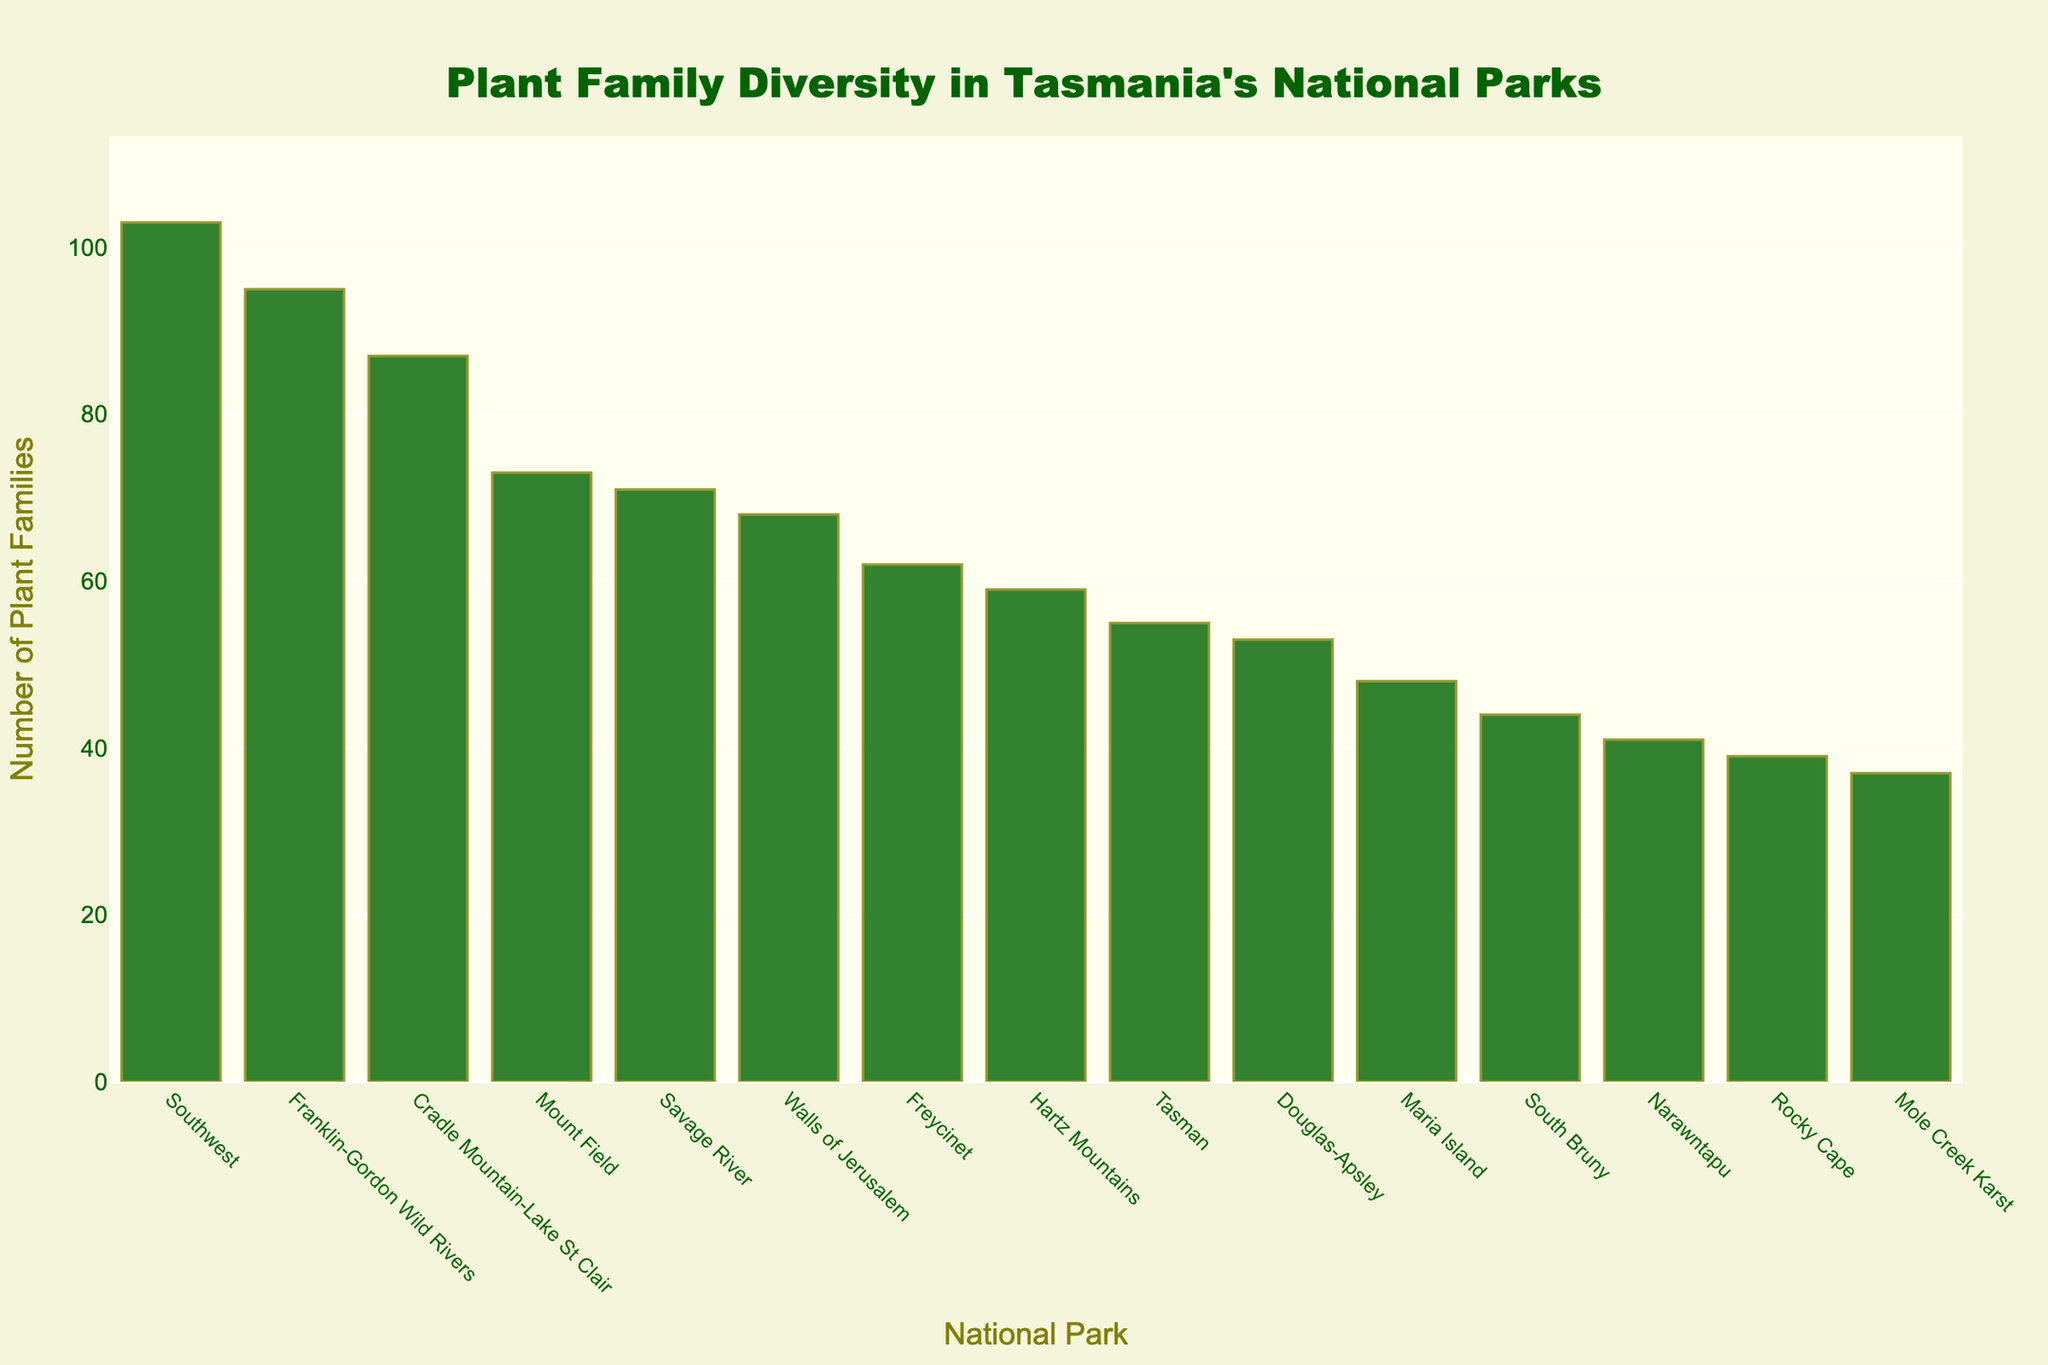Which national park has the highest diversity of plant families? By looking at the bar heights, the tallest bar corresponds to the Southwest National Park.
Answer: Southwest Which national park has the lowest plant family count? By looking at the shortest bar in the chart, it corresponds to Mole Creek Karst National Park.
Answer: Mole Creek Karst How many plant families are there in Freycinet and Hartz Mountains combined? From the figure, Freycinet has 62 plant families, and Hartz Mountains has 59. Adding them together gives 62 + 59 = 121.
Answer: 121 Which national parks have a plant family count greater than 70 but less than 100? By observing the bars in the 70 to 100 range, Mount Field (73), Franklin-Gordon Wild Rivers (95), and Savage River (71) fall within this range.
Answer: Mount Field, Franklin-Gordon Wild Rivers, Savage River What is the total count of plant families in Tasman and Maria Island national parks? From the chart, Tasman has 55 plant families, and Maria Island has 48. Adding these together gives 55 + 48 = 103.
Answer: 103 How many national parks have a plant family count less than 50? By counting the bars below the 50 mark, the parks are Maria Island (48), Narawntapu (41), Mole Creek Karst (37), South Bruny (44), and Rocky Cape (39). This gives a total of 5 parks.
Answer: 5 By what percentage is the plant family count in Southwest National Park greater than in Cradle Mountain-Lake St Clair National Park? Southwest has 103 families, and Cradle Mountain-Lake St Clair has 87. The difference is 103 - 87 = 16. The percentage increase is (16 / 87) * 100 ≈ 18.39%.
Answer: 18.39% What is the average number of plant families in the national parks? Sum the plant family counts: 87 + 62 + 73 + 95 + 103 + 55 + 48 + 68 + 59 + 41 + 53 + 37 + 44 + 39 + 71 = 936. There are 15 parks, so the average is 936 / 15 = 62.4.
Answer: 62.4 Which national park has a plant family count closest to the average? The average is 62.4. By comparing the counts to this value, Freycinet has 62 plant families, which is the closest to 62.4.
Answer: Freycinet How many national parks have more than 60 plant families? Counting the bars taller than the 60 mark, we find Cradle Mountain-Lake St Clair (87), Freycinet (62), Mount Field (73), Franklin-Gordon Wild Rivers (95), Southwest (103), Walls of Jerusalem (68), and Savage River (71). This gives a total of 7 parks.
Answer: 7 